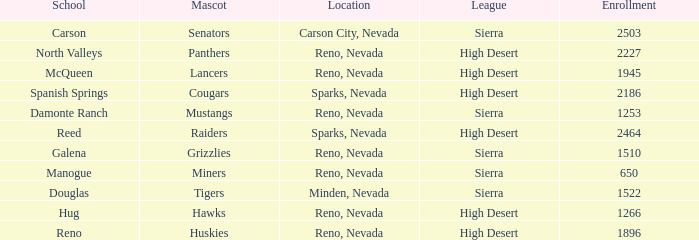What city and state is the Lancers mascot located? Reno, Nevada. Give me the full table as a dictionary. {'header': ['School', 'Mascot', 'Location', 'League', 'Enrollment'], 'rows': [['Carson', 'Senators', 'Carson City, Nevada', 'Sierra', '2503'], ['North Valleys', 'Panthers', 'Reno, Nevada', 'High Desert', '2227'], ['McQueen', 'Lancers', 'Reno, Nevada', 'High Desert', '1945'], ['Spanish Springs', 'Cougars', 'Sparks, Nevada', 'High Desert', '2186'], ['Damonte Ranch', 'Mustangs', 'Reno, Nevada', 'Sierra', '1253'], ['Reed', 'Raiders', 'Sparks, Nevada', 'High Desert', '2464'], ['Galena', 'Grizzlies', 'Reno, Nevada', 'Sierra', '1510'], ['Manogue', 'Miners', 'Reno, Nevada', 'Sierra', '650'], ['Douglas', 'Tigers', 'Minden, Nevada', 'Sierra', '1522'], ['Hug', 'Hawks', 'Reno, Nevada', 'High Desert', '1266'], ['Reno', 'Huskies', 'Reno, Nevada', 'High Desert', '1896']]} 